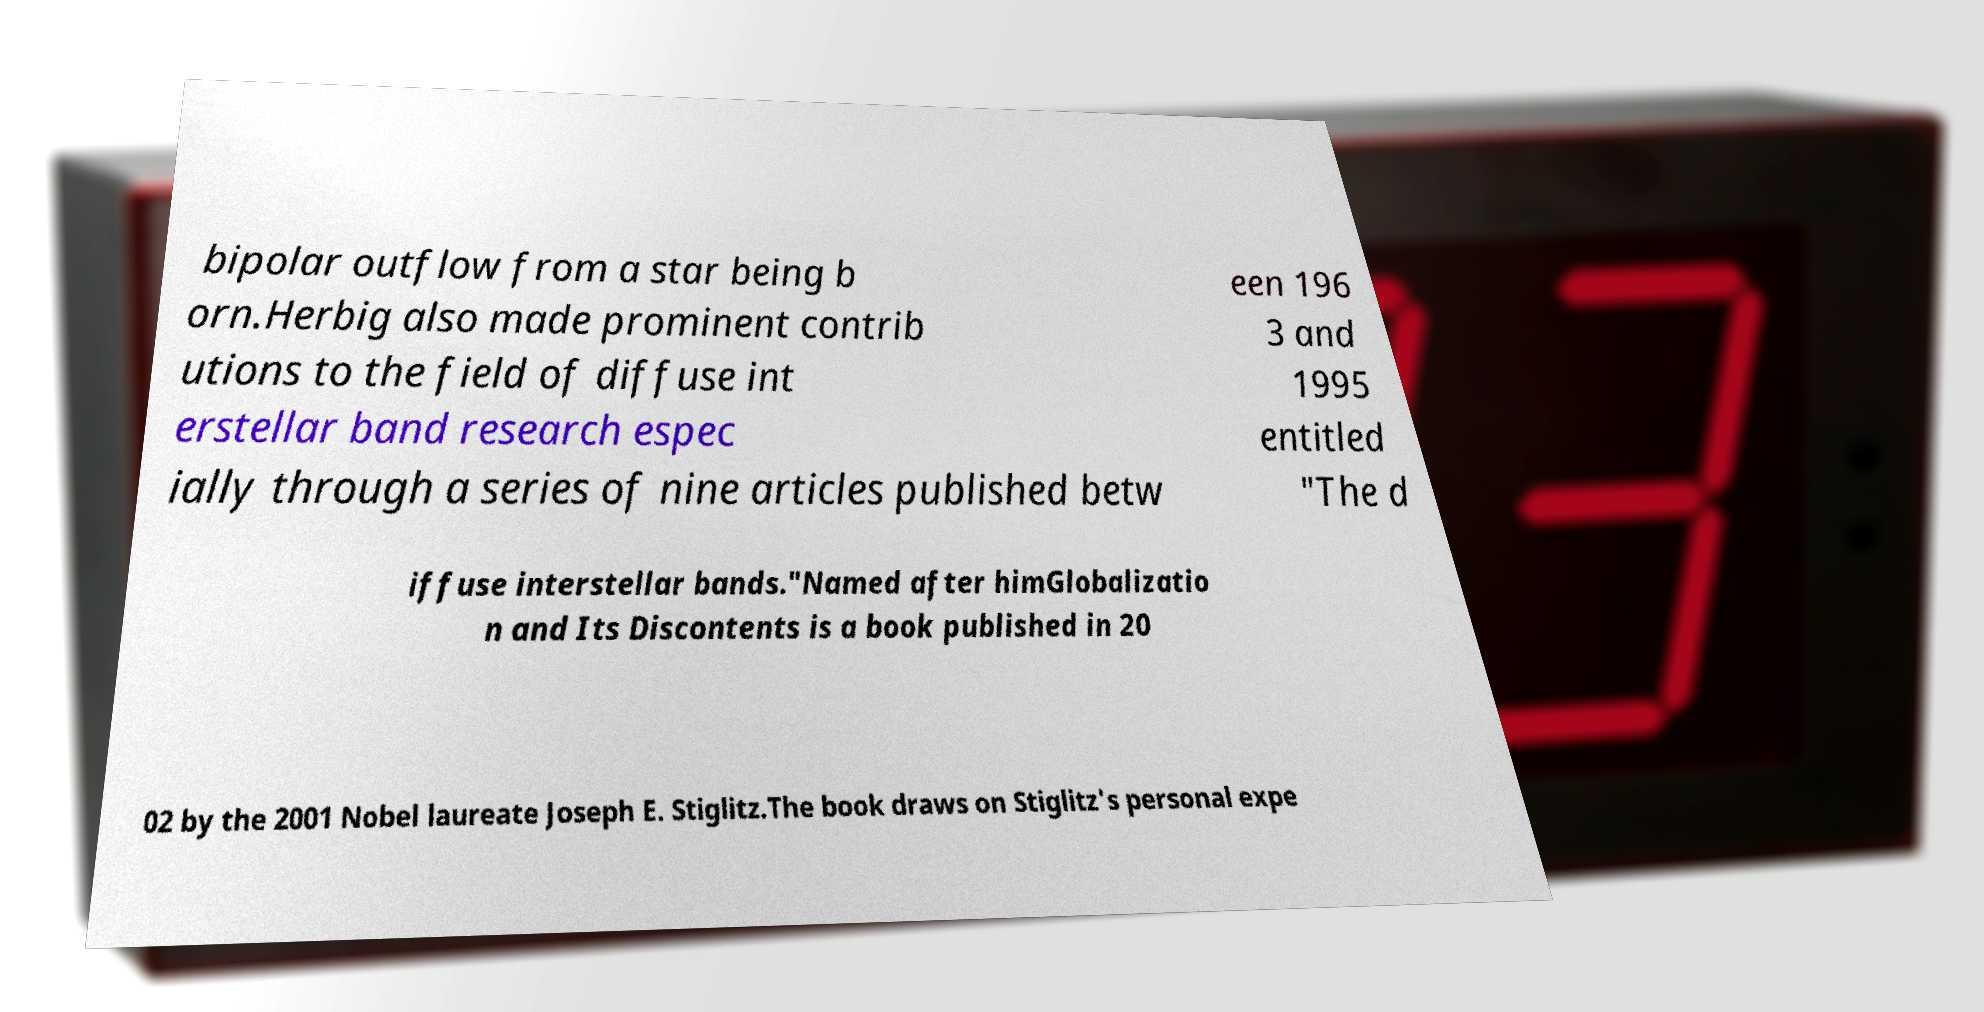Could you assist in decoding the text presented in this image and type it out clearly? bipolar outflow from a star being b orn.Herbig also made prominent contrib utions to the field of diffuse int erstellar band research espec ially through a series of nine articles published betw een 196 3 and 1995 entitled "The d iffuse interstellar bands."Named after himGlobalizatio n and Its Discontents is a book published in 20 02 by the 2001 Nobel laureate Joseph E. Stiglitz.The book draws on Stiglitz's personal expe 